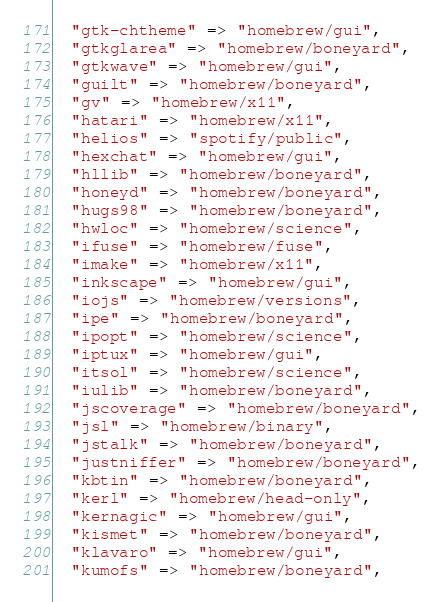Convert code to text. <code><loc_0><loc_0><loc_500><loc_500><_Ruby_>  "gtk-chtheme" => "homebrew/gui",
  "gtkglarea" => "homebrew/boneyard",
  "gtkwave" => "homebrew/gui",
  "guilt" => "homebrew/boneyard",
  "gv" => "homebrew/x11",
  "hatari" => "homebrew/x11",
  "helios" => "spotify/public",
  "hexchat" => "homebrew/gui",
  "hllib" => "homebrew/boneyard",
  "honeyd" => "homebrew/boneyard",
  "hugs98" => "homebrew/boneyard",
  "hwloc" => "homebrew/science",
  "ifuse" => "homebrew/fuse",
  "imake" => "homebrew/x11",
  "inkscape" => "homebrew/gui",
  "iojs" => "homebrew/versions",
  "ipe" => "homebrew/boneyard",
  "ipopt" => "homebrew/science",
  "iptux" => "homebrew/gui",
  "itsol" => "homebrew/science",
  "iulib" => "homebrew/boneyard",
  "jscoverage" => "homebrew/boneyard",
  "jsl" => "homebrew/binary",
  "jstalk" => "homebrew/boneyard",
  "justniffer" => "homebrew/boneyard",
  "kbtin" => "homebrew/boneyard",
  "kerl" => "homebrew/head-only",
  "kernagic" => "homebrew/gui",
  "kismet" => "homebrew/boneyard",
  "klavaro" => "homebrew/gui",
  "kumofs" => "homebrew/boneyard",</code> 